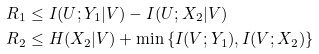<formula> <loc_0><loc_0><loc_500><loc_500>R _ { 1 } & \leq I ( U ; Y _ { 1 } | V ) - I ( U ; X _ { 2 } | V ) \\ R _ { 2 } & \leq H ( X _ { 2 } | V ) + \min \left \{ I ( V ; Y _ { 1 } ) , I ( V ; X _ { 2 } ) \right \}</formula> 